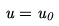<formula> <loc_0><loc_0><loc_500><loc_500>u = u _ { 0 }</formula> 